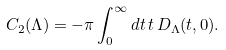Convert formula to latex. <formula><loc_0><loc_0><loc_500><loc_500>C _ { 2 } ( \Lambda ) = - \pi \int _ { 0 } ^ { \infty } d t \, t \, D _ { \Lambda } ( t , 0 ) .</formula> 